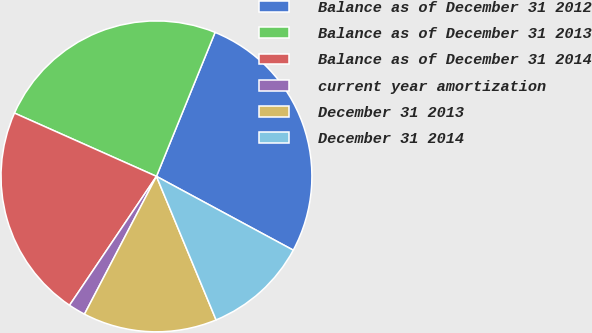<chart> <loc_0><loc_0><loc_500><loc_500><pie_chart><fcel>Balance as of December 31 2012<fcel>Balance as of December 31 2013<fcel>Balance as of December 31 2014<fcel>current year amortization<fcel>December 31 2013<fcel>December 31 2014<nl><fcel>26.72%<fcel>24.48%<fcel>22.23%<fcel>1.78%<fcel>13.93%<fcel>10.86%<nl></chart> 